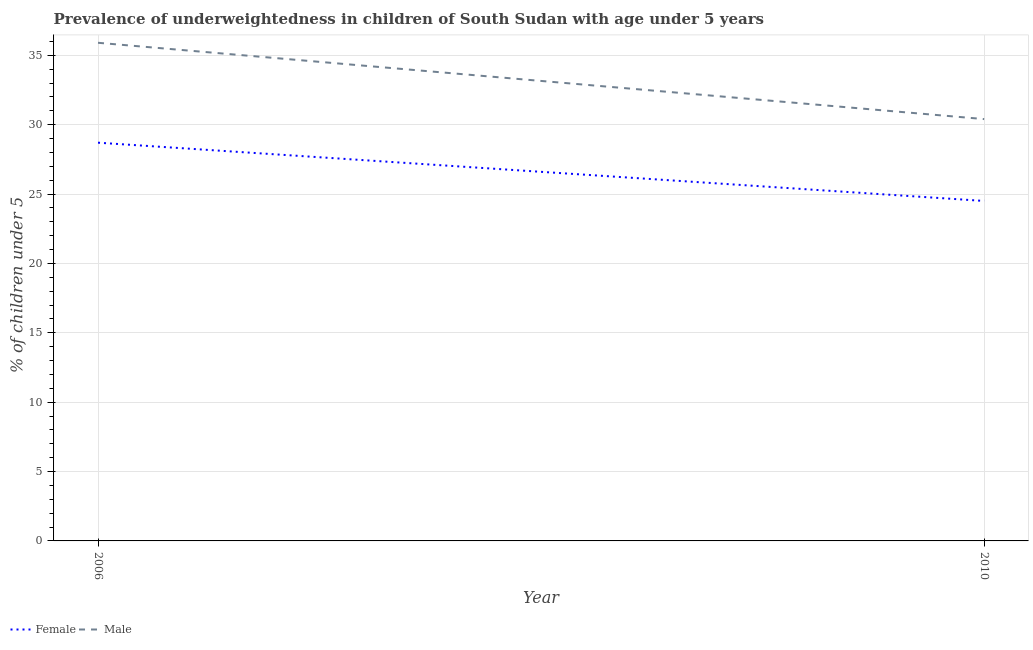What is the percentage of underweighted male children in 2006?
Ensure brevity in your answer.  35.9. Across all years, what is the maximum percentage of underweighted female children?
Provide a succinct answer. 28.7. Across all years, what is the minimum percentage of underweighted female children?
Provide a short and direct response. 24.5. What is the total percentage of underweighted male children in the graph?
Offer a terse response. 66.3. What is the difference between the percentage of underweighted female children in 2006 and that in 2010?
Offer a very short reply. 4.2. What is the difference between the percentage of underweighted female children in 2006 and the percentage of underweighted male children in 2010?
Provide a short and direct response. -1.7. What is the average percentage of underweighted male children per year?
Give a very brief answer. 33.15. In the year 2006, what is the difference between the percentage of underweighted male children and percentage of underweighted female children?
Your answer should be compact. 7.2. In how many years, is the percentage of underweighted male children greater than 11 %?
Provide a succinct answer. 2. What is the ratio of the percentage of underweighted female children in 2006 to that in 2010?
Your answer should be very brief. 1.17. Is the percentage of underweighted female children in 2006 less than that in 2010?
Provide a succinct answer. No. In how many years, is the percentage of underweighted male children greater than the average percentage of underweighted male children taken over all years?
Give a very brief answer. 1. Does the percentage of underweighted male children monotonically increase over the years?
Give a very brief answer. No. Is the percentage of underweighted male children strictly less than the percentage of underweighted female children over the years?
Your answer should be very brief. No. How many years are there in the graph?
Give a very brief answer. 2. What is the difference between two consecutive major ticks on the Y-axis?
Make the answer very short. 5. How are the legend labels stacked?
Your answer should be very brief. Horizontal. What is the title of the graph?
Your answer should be very brief. Prevalence of underweightedness in children of South Sudan with age under 5 years. Does "Highest 10% of population" appear as one of the legend labels in the graph?
Your answer should be compact. No. What is the label or title of the Y-axis?
Provide a succinct answer.  % of children under 5. What is the  % of children under 5 of Female in 2006?
Your response must be concise. 28.7. What is the  % of children under 5 of Male in 2006?
Your response must be concise. 35.9. What is the  % of children under 5 in Male in 2010?
Keep it short and to the point. 30.4. Across all years, what is the maximum  % of children under 5 in Female?
Your answer should be compact. 28.7. Across all years, what is the maximum  % of children under 5 in Male?
Keep it short and to the point. 35.9. Across all years, what is the minimum  % of children under 5 of Female?
Your answer should be very brief. 24.5. Across all years, what is the minimum  % of children under 5 in Male?
Offer a very short reply. 30.4. What is the total  % of children under 5 of Female in the graph?
Your answer should be very brief. 53.2. What is the total  % of children under 5 of Male in the graph?
Keep it short and to the point. 66.3. What is the difference between the  % of children under 5 of Female in 2006 and that in 2010?
Provide a short and direct response. 4.2. What is the average  % of children under 5 of Female per year?
Give a very brief answer. 26.6. What is the average  % of children under 5 in Male per year?
Provide a short and direct response. 33.15. What is the ratio of the  % of children under 5 in Female in 2006 to that in 2010?
Provide a short and direct response. 1.17. What is the ratio of the  % of children under 5 in Male in 2006 to that in 2010?
Make the answer very short. 1.18. What is the difference between the highest and the second highest  % of children under 5 of Female?
Your response must be concise. 4.2. What is the difference between the highest and the lowest  % of children under 5 of Female?
Your answer should be very brief. 4.2. 